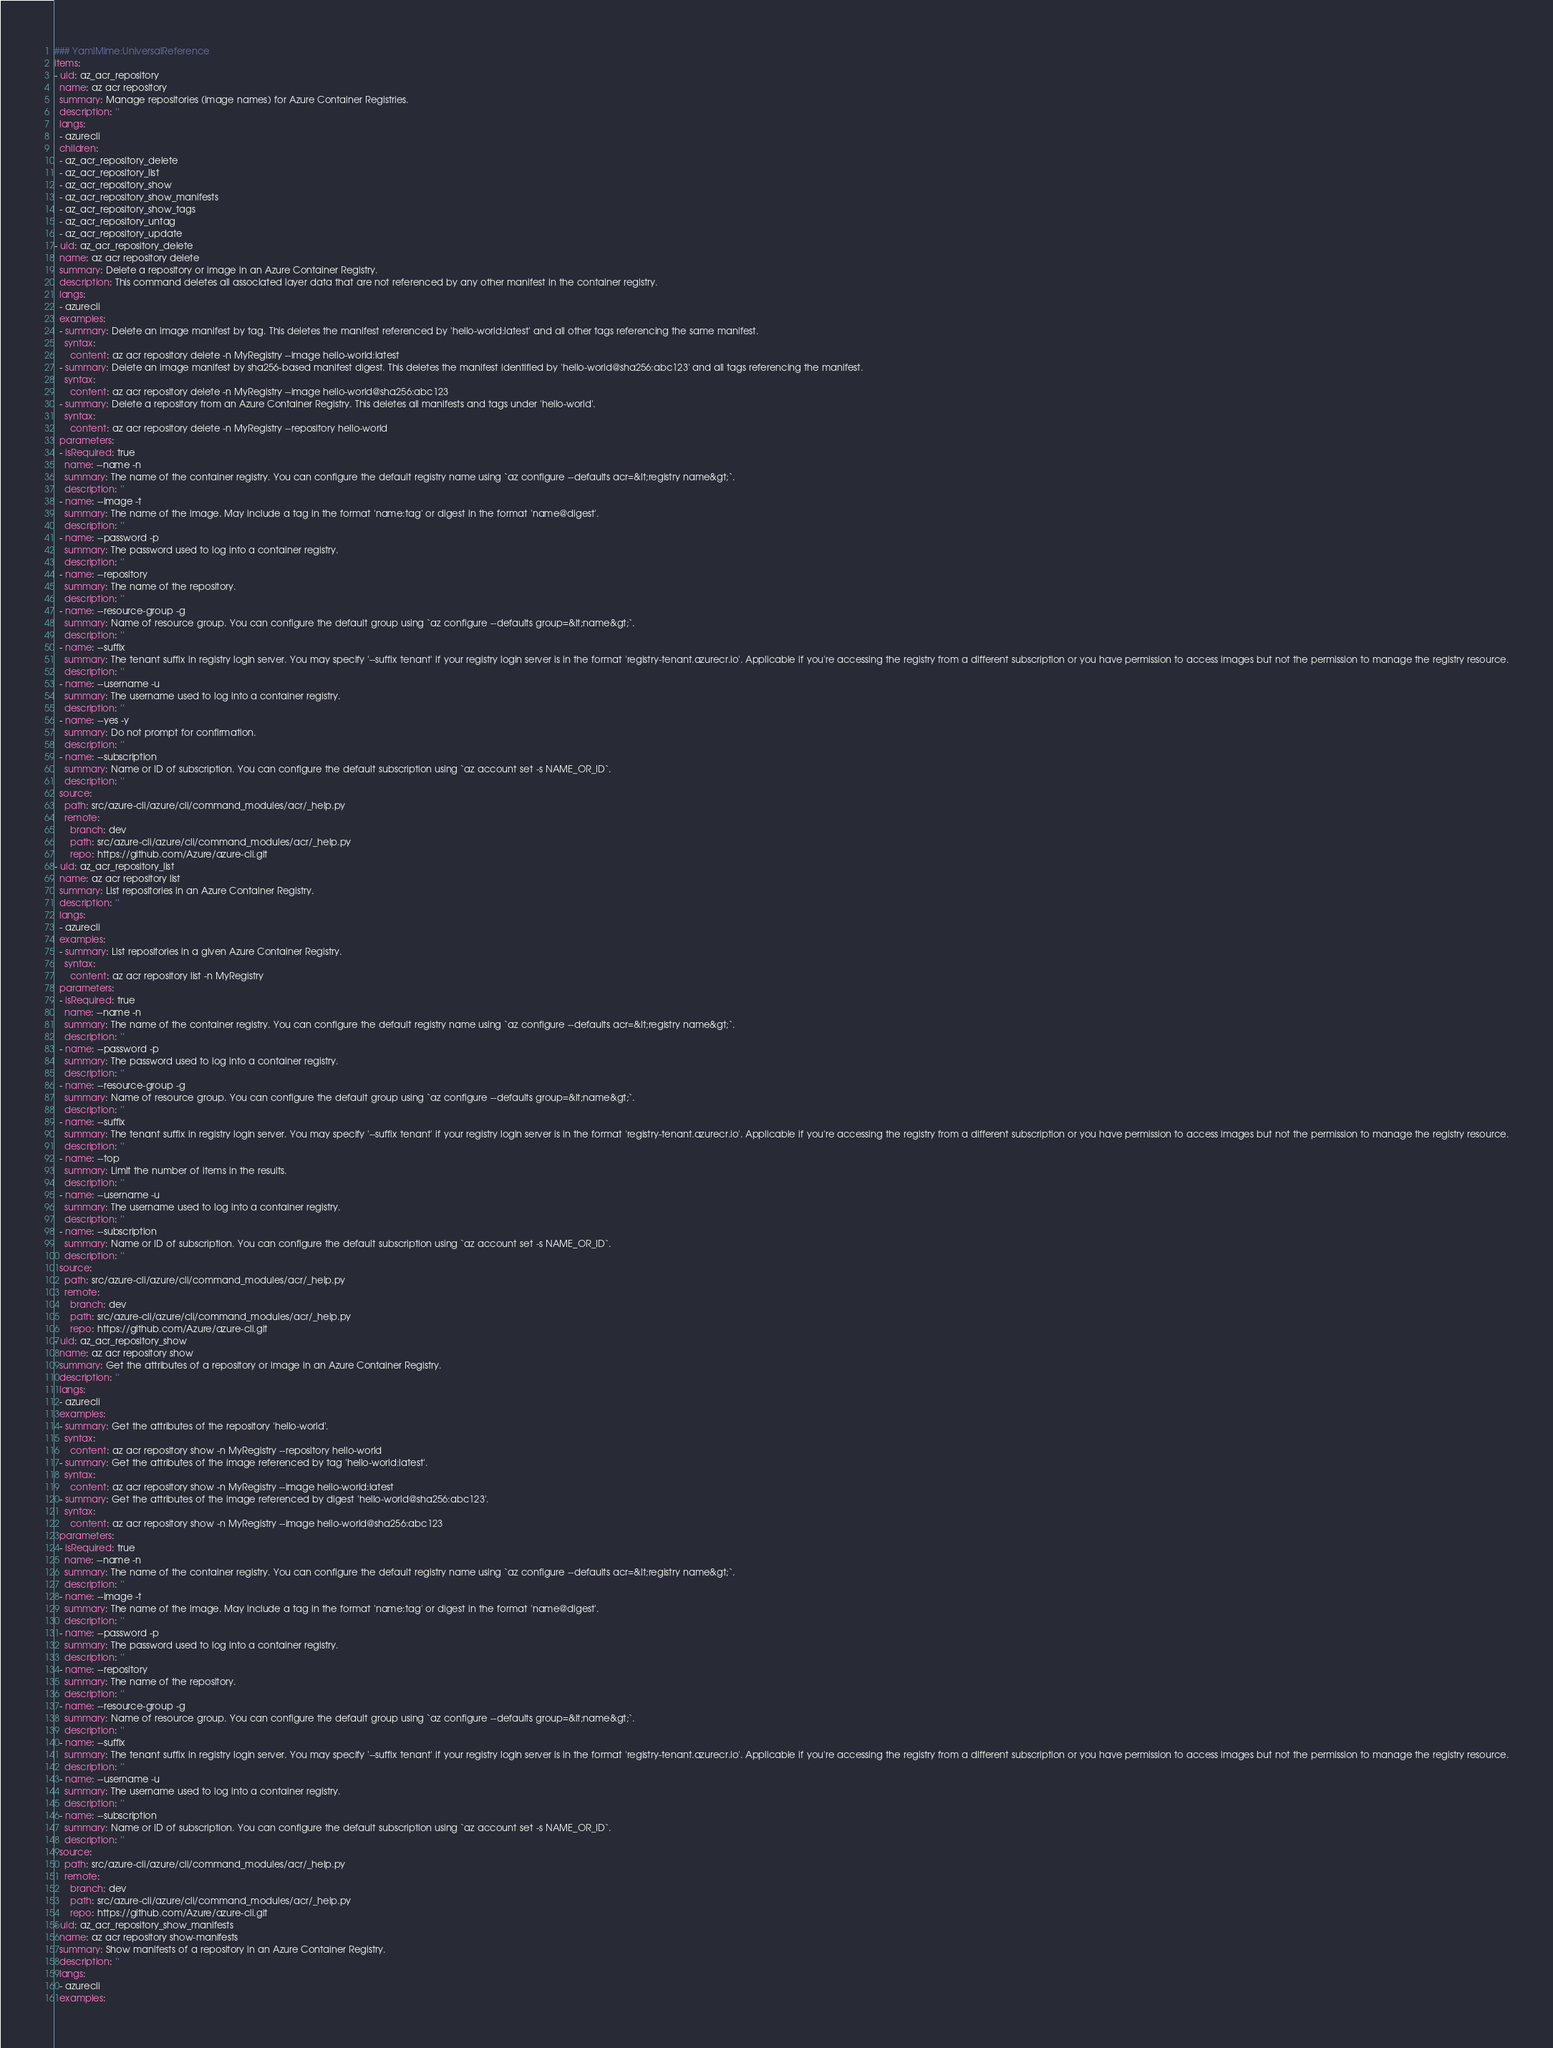<code> <loc_0><loc_0><loc_500><loc_500><_YAML_>### YamlMime:UniversalReference
items:
- uid: az_acr_repository
  name: az acr repository
  summary: Manage repositories (image names) for Azure Container Registries.
  description: ''
  langs:
  - azurecli
  children:
  - az_acr_repository_delete
  - az_acr_repository_list
  - az_acr_repository_show
  - az_acr_repository_show_manifests
  - az_acr_repository_show_tags
  - az_acr_repository_untag
  - az_acr_repository_update
- uid: az_acr_repository_delete
  name: az acr repository delete
  summary: Delete a repository or image in an Azure Container Registry.
  description: This command deletes all associated layer data that are not referenced by any other manifest in the container registry.
  langs:
  - azurecli
  examples:
  - summary: Delete an image manifest by tag. This deletes the manifest referenced by 'hello-world:latest' and all other tags referencing the same manifest.
    syntax:
      content: az acr repository delete -n MyRegistry --image hello-world:latest
  - summary: Delete an image manifest by sha256-based manifest digest. This deletes the manifest identified by 'hello-world@sha256:abc123' and all tags referencing the manifest.
    syntax:
      content: az acr repository delete -n MyRegistry --image hello-world@sha256:abc123
  - summary: Delete a repository from an Azure Container Registry. This deletes all manifests and tags under 'hello-world'.
    syntax:
      content: az acr repository delete -n MyRegistry --repository hello-world
  parameters:
  - isRequired: true
    name: --name -n
    summary: The name of the container registry. You can configure the default registry name using `az configure --defaults acr=&lt;registry name&gt;`.
    description: ''
  - name: --image -t
    summary: The name of the image. May include a tag in the format 'name:tag' or digest in the format 'name@digest'.
    description: ''
  - name: --password -p
    summary: The password used to log into a container registry.
    description: ''
  - name: --repository
    summary: The name of the repository.
    description: ''
  - name: --resource-group -g
    summary: Name of resource group. You can configure the default group using `az configure --defaults group=&lt;name&gt;`.
    description: ''
  - name: --suffix
    summary: The tenant suffix in registry login server. You may specify '--suffix tenant' if your registry login server is in the format 'registry-tenant.azurecr.io'. Applicable if you're accessing the registry from a different subscription or you have permission to access images but not the permission to manage the registry resource.
    description: ''
  - name: --username -u
    summary: The username used to log into a container registry.
    description: ''
  - name: --yes -y
    summary: Do not prompt for confirmation.
    description: ''
  - name: --subscription
    summary: Name or ID of subscription. You can configure the default subscription using `az account set -s NAME_OR_ID`.
    description: ''
  source:
    path: src/azure-cli/azure/cli/command_modules/acr/_help.py
    remote:
      branch: dev
      path: src/azure-cli/azure/cli/command_modules/acr/_help.py
      repo: https://github.com/Azure/azure-cli.git
- uid: az_acr_repository_list
  name: az acr repository list
  summary: List repositories in an Azure Container Registry.
  description: ''
  langs:
  - azurecli
  examples:
  - summary: List repositories in a given Azure Container Registry.
    syntax:
      content: az acr repository list -n MyRegistry
  parameters:
  - isRequired: true
    name: --name -n
    summary: The name of the container registry. You can configure the default registry name using `az configure --defaults acr=&lt;registry name&gt;`.
    description: ''
  - name: --password -p
    summary: The password used to log into a container registry.
    description: ''
  - name: --resource-group -g
    summary: Name of resource group. You can configure the default group using `az configure --defaults group=&lt;name&gt;`.
    description: ''
  - name: --suffix
    summary: The tenant suffix in registry login server. You may specify '--suffix tenant' if your registry login server is in the format 'registry-tenant.azurecr.io'. Applicable if you're accessing the registry from a different subscription or you have permission to access images but not the permission to manage the registry resource.
    description: ''
  - name: --top
    summary: Limit the number of items in the results.
    description: ''
  - name: --username -u
    summary: The username used to log into a container registry.
    description: ''
  - name: --subscription
    summary: Name or ID of subscription. You can configure the default subscription using `az account set -s NAME_OR_ID`.
    description: ''
  source:
    path: src/azure-cli/azure/cli/command_modules/acr/_help.py
    remote:
      branch: dev
      path: src/azure-cli/azure/cli/command_modules/acr/_help.py
      repo: https://github.com/Azure/azure-cli.git
- uid: az_acr_repository_show
  name: az acr repository show
  summary: Get the attributes of a repository or image in an Azure Container Registry.
  description: ''
  langs:
  - azurecli
  examples:
  - summary: Get the attributes of the repository 'hello-world'.
    syntax:
      content: az acr repository show -n MyRegistry --repository hello-world
  - summary: Get the attributes of the image referenced by tag 'hello-world:latest'.
    syntax:
      content: az acr repository show -n MyRegistry --image hello-world:latest
  - summary: Get the attributes of the image referenced by digest 'hello-world@sha256:abc123'.
    syntax:
      content: az acr repository show -n MyRegistry --image hello-world@sha256:abc123
  parameters:
  - isRequired: true
    name: --name -n
    summary: The name of the container registry. You can configure the default registry name using `az configure --defaults acr=&lt;registry name&gt;`.
    description: ''
  - name: --image -t
    summary: The name of the image. May include a tag in the format 'name:tag' or digest in the format 'name@digest'.
    description: ''
  - name: --password -p
    summary: The password used to log into a container registry.
    description: ''
  - name: --repository
    summary: The name of the repository.
    description: ''
  - name: --resource-group -g
    summary: Name of resource group. You can configure the default group using `az configure --defaults group=&lt;name&gt;`.
    description: ''
  - name: --suffix
    summary: The tenant suffix in registry login server. You may specify '--suffix tenant' if your registry login server is in the format 'registry-tenant.azurecr.io'. Applicable if you're accessing the registry from a different subscription or you have permission to access images but not the permission to manage the registry resource.
    description: ''
  - name: --username -u
    summary: The username used to log into a container registry.
    description: ''
  - name: --subscription
    summary: Name or ID of subscription. You can configure the default subscription using `az account set -s NAME_OR_ID`.
    description: ''
  source:
    path: src/azure-cli/azure/cli/command_modules/acr/_help.py
    remote:
      branch: dev
      path: src/azure-cli/azure/cli/command_modules/acr/_help.py
      repo: https://github.com/Azure/azure-cli.git
- uid: az_acr_repository_show_manifests
  name: az acr repository show-manifests
  summary: Show manifests of a repository in an Azure Container Registry.
  description: ''
  langs:
  - azurecli
  examples:</code> 